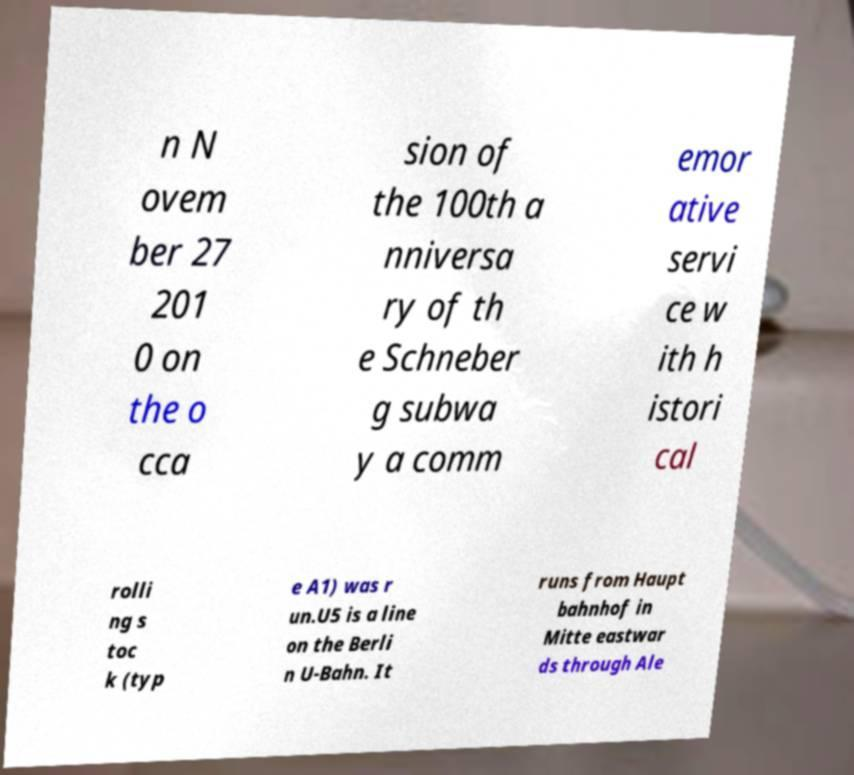Please identify and transcribe the text found in this image. n N ovem ber 27 201 0 on the o cca sion of the 100th a nniversa ry of th e Schneber g subwa y a comm emor ative servi ce w ith h istori cal rolli ng s toc k (typ e A1) was r un.U5 is a line on the Berli n U-Bahn. It runs from Haupt bahnhof in Mitte eastwar ds through Ale 